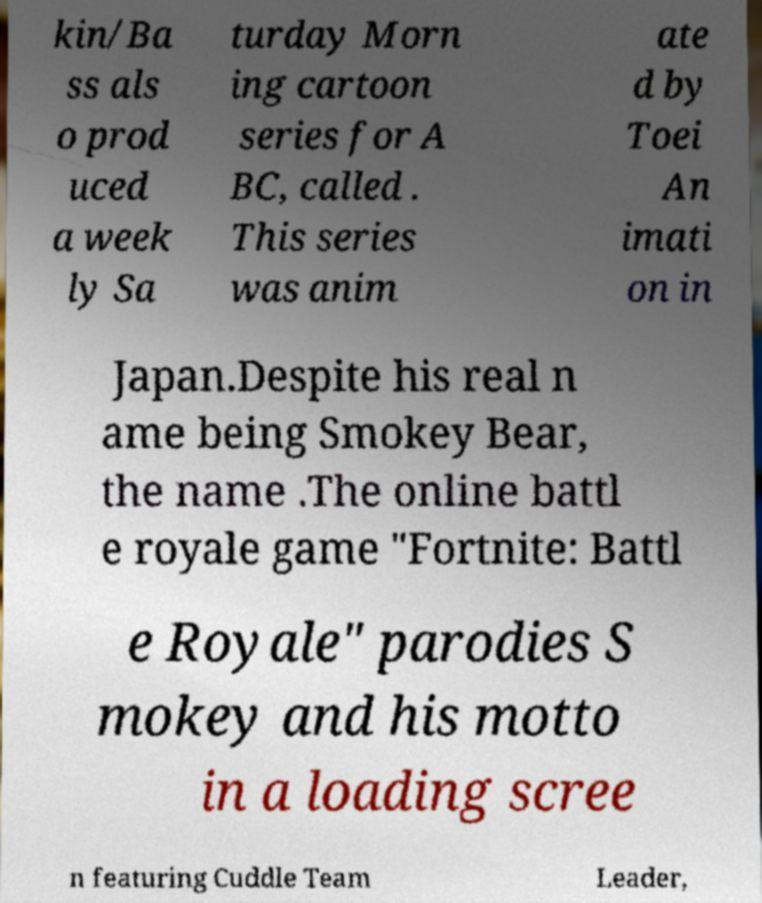Please read and relay the text visible in this image. What does it say? kin/Ba ss als o prod uced a week ly Sa turday Morn ing cartoon series for A BC, called . This series was anim ate d by Toei An imati on in Japan.Despite his real n ame being Smokey Bear, the name .The online battl e royale game "Fortnite: Battl e Royale" parodies S mokey and his motto in a loading scree n featuring Cuddle Team Leader, 